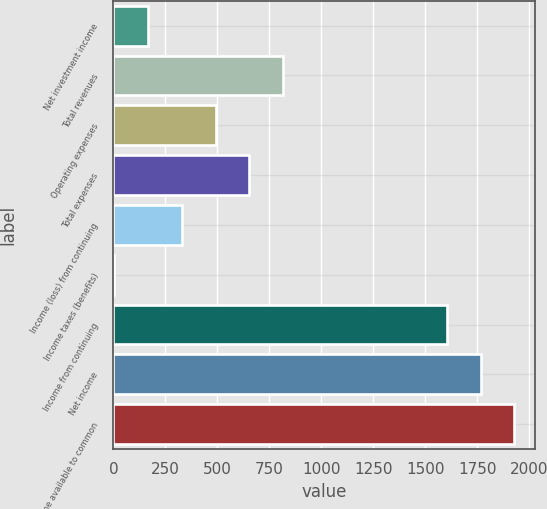Convert chart to OTSL. <chart><loc_0><loc_0><loc_500><loc_500><bar_chart><fcel>Net investment income<fcel>Total revenues<fcel>Operating expenses<fcel>Total expenses<fcel>Income (loss) from continuing<fcel>Income taxes (benefits)<fcel>Income from continuing<fcel>Net income<fcel>Net income available to common<nl><fcel>166.95<fcel>815.15<fcel>491.05<fcel>653.1<fcel>329<fcel>4.9<fcel>1605.2<fcel>1767.25<fcel>1929.3<nl></chart> 